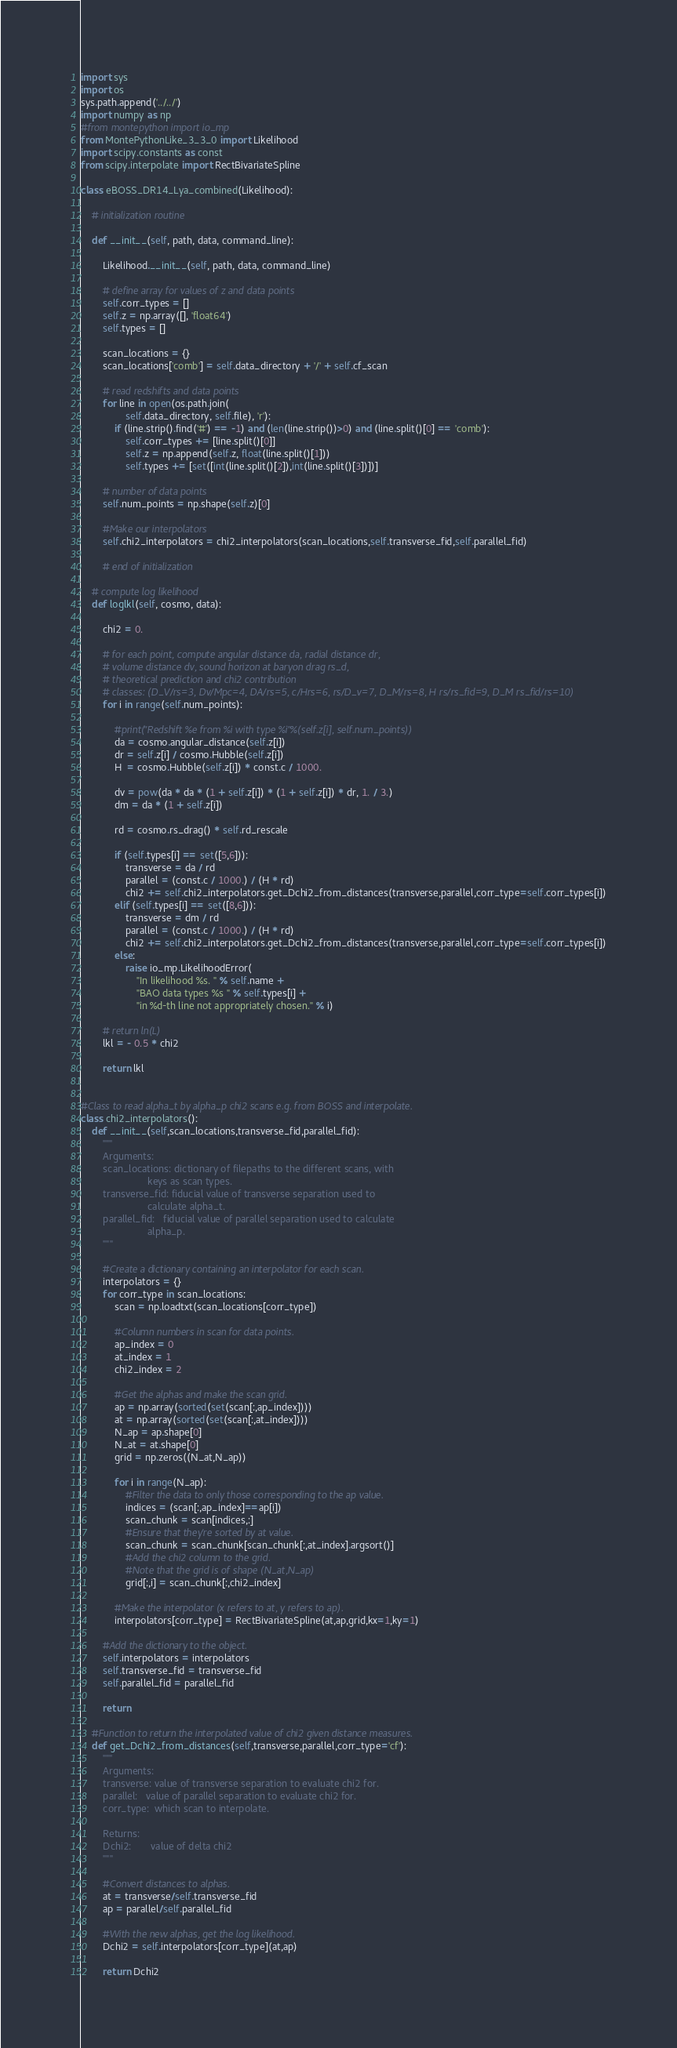Convert code to text. <code><loc_0><loc_0><loc_500><loc_500><_Python_>import sys 
import os
sys.path.append('../../')
import numpy as np
#from montepython import io_mp
from MontePythonLike_3_3_0 import Likelihood
import scipy.constants as const
from scipy.interpolate import RectBivariateSpline

class eBOSS_DR14_Lya_combined(Likelihood):

    # initialization routine

    def __init__(self, path, data, command_line):

        Likelihood.__init__(self, path, data, command_line)

        # define array for values of z and data points
        self.corr_types = []
        self.z = np.array([], 'float64')
        self.types = []

        scan_locations = {}
        scan_locations['comb'] = self.data_directory + '/' + self.cf_scan

        # read redshifts and data points
        for line in open(os.path.join(
                self.data_directory, self.file), 'r'):
            if (line.strip().find('#') == -1) and (len(line.strip())>0) and (line.split()[0] == 'comb'):
                self.corr_types += [line.split()[0]]
                self.z = np.append(self.z, float(line.split()[1]))
                self.types += [set([int(line.split()[2]),int(line.split()[3])])]

        # number of data points
        self.num_points = np.shape(self.z)[0]

        #Make our interpolators
        self.chi2_interpolators = chi2_interpolators(scan_locations,self.transverse_fid,self.parallel_fid)

        # end of initialization

    # compute log likelihood
    def loglkl(self, cosmo, data):

        chi2 = 0.

        # for each point, compute angular distance da, radial distance dr,
        # volume distance dv, sound horizon at baryon drag rs_d,
        # theoretical prediction and chi2 contribution
        # classes: (D_V/rs=3, Dv/Mpc=4, DA/rs=5, c/Hrs=6, rs/D_v=7, D_M/rs=8, H rs/rs_fid=9, D_M rs_fid/rs=10)
        for i in range(self.num_points):

            #print("Redshift %e from %i with type %i"%(self.z[i], self.num_points))
            da = cosmo.angular_distance(self.z[i])
            dr = self.z[i] / cosmo.Hubble(self.z[i])
            H  = cosmo.Hubble(self.z[i]) * const.c / 1000.

            dv = pow(da * da * (1 + self.z[i]) * (1 + self.z[i]) * dr, 1. / 3.)
            dm = da * (1 + self.z[i])

            rd = cosmo.rs_drag() * self.rd_rescale

            if (self.types[i] == set([5,6])):
                transverse = da / rd
                parallel = (const.c / 1000.) / (H * rd)
                chi2 += self.chi2_interpolators.get_Dchi2_from_distances(transverse,parallel,corr_type=self.corr_types[i])
            elif (self.types[i] == set([8,6])):
                transverse = dm / rd
                parallel = (const.c / 1000.) / (H * rd)
                chi2 += self.chi2_interpolators.get_Dchi2_from_distances(transverse,parallel,corr_type=self.corr_types[i])
            else:
                raise io_mp.LikelihoodError(
                    "In likelihood %s. " % self.name +
                    "BAO data types %s " % self.types[i] +
                    "in %d-th line not appropriately chosen." % i)

        # return ln(L)
        lkl = - 0.5 * chi2

        return lkl


#Class to read alpha_t by alpha_p chi2 scans e.g. from BOSS and interpolate.
class chi2_interpolators():
    def __init__(self,scan_locations,transverse_fid,parallel_fid):
        """
        Arguments:
        scan_locations: dictionary of filepaths to the different scans, with
                        keys as scan types.
        transverse_fid: fiducial value of transverse separation used to
                        calculate alpha_t.
        parallel_fid:   fiducial value of parallel separation used to calculate
                        alpha_p.
        """

        #Create a dictionary containing an interpolator for each scan.
        interpolators = {}
        for corr_type in scan_locations:
            scan = np.loadtxt(scan_locations[corr_type])

            #Column numbers in scan for data points.
            ap_index = 0
            at_index = 1
            chi2_index = 2

            #Get the alphas and make the scan grid.
            ap = np.array(sorted(set(scan[:,ap_index])))
            at = np.array(sorted(set(scan[:,at_index])))
            N_ap = ap.shape[0]
            N_at = at.shape[0]
            grid = np.zeros((N_at,N_ap))

            for i in range(N_ap):
                #Filter the data to only those corresponding to the ap value.
                indices = (scan[:,ap_index]==ap[i])
                scan_chunk = scan[indices,:]
                #Ensure that they're sorted by at value.
                scan_chunk = scan_chunk[scan_chunk[:,at_index].argsort()]
                #Add the chi2 column to the grid.
                #Note that the grid is of shape (N_at,N_ap)
                grid[:,i] = scan_chunk[:,chi2_index]

            #Make the interpolator (x refers to at, y refers to ap).
            interpolators[corr_type] = RectBivariateSpline(at,ap,grid,kx=1,ky=1)

        #Add the dictionary to the object.
        self.interpolators = interpolators
        self.transverse_fid = transverse_fid
        self.parallel_fid = parallel_fid

        return

    #Function to return the interpolated value of chi2 given distance measures.
    def get_Dchi2_from_distances(self,transverse,parallel,corr_type='cf'):
        """
        Arguments:
        transverse: value of transverse separation to evaluate chi2 for.
        parallel:   value of parallel separation to evaluate chi2 for.
        corr_type:  which scan to interpolate.

        Returns:
        Dchi2:       value of delta chi2
        """

        #Convert distances to alphas.
        at = transverse/self.transverse_fid
        ap = parallel/self.parallel_fid

        #With the new alphas, get the log likelihood.
        Dchi2 = self.interpolators[corr_type](at,ap)

        return Dchi2
</code> 